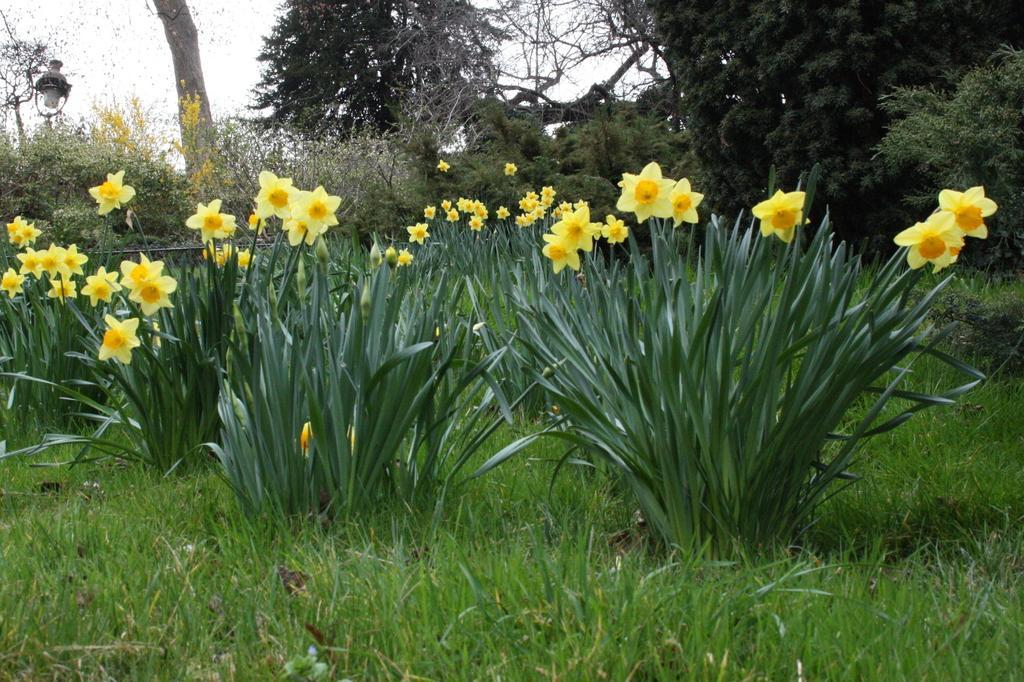Can you describe this image briefly? In this picture we can see some grass on the ground. There are a few flowers, plants and trees. We can see an object on the left side. 